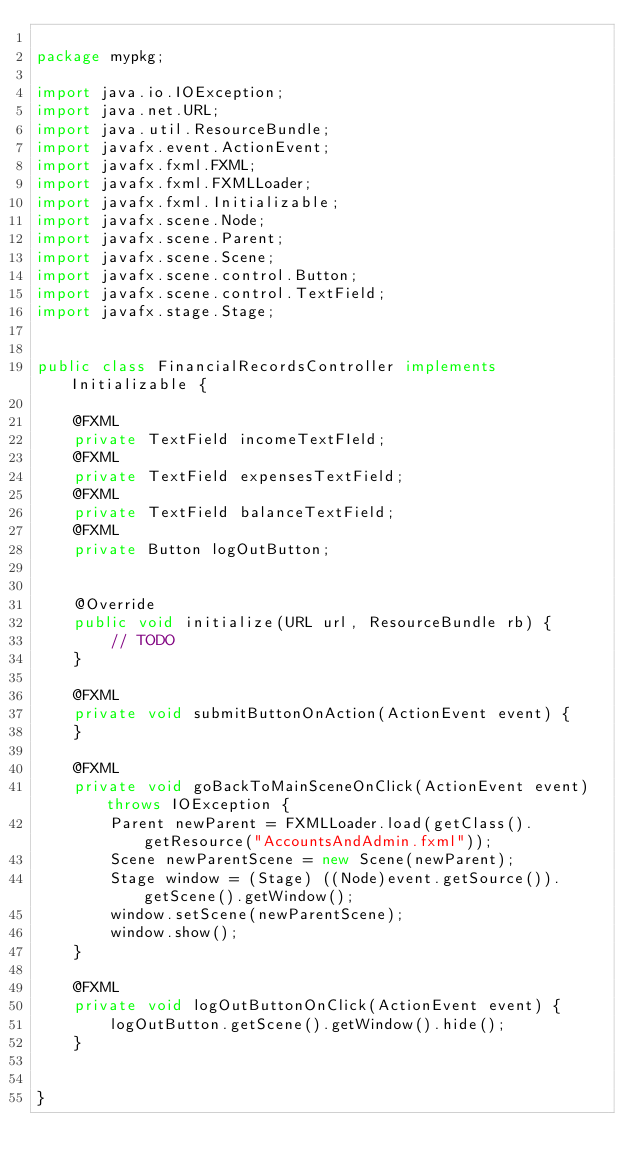<code> <loc_0><loc_0><loc_500><loc_500><_Java_> 
package mypkg;

import java.io.IOException;
import java.net.URL;
import java.util.ResourceBundle;
import javafx.event.ActionEvent;
import javafx.fxml.FXML;
import javafx.fxml.FXMLLoader;
import javafx.fxml.Initializable;
import javafx.scene.Node;
import javafx.scene.Parent;
import javafx.scene.Scene;
import javafx.scene.control.Button;
import javafx.scene.control.TextField;
import javafx.stage.Stage;

 
public class FinancialRecordsController implements Initializable {

    @FXML
    private TextField incomeTextFIeld;
    @FXML
    private TextField expensesTextField;
    @FXML
    private TextField balanceTextField;
    @FXML
    private Button logOutButton;

     
    @Override
    public void initialize(URL url, ResourceBundle rb) {
        // TODO
    }    

    @FXML
    private void submitButtonOnAction(ActionEvent event) {
    }

    @FXML
    private void goBackToMainSceneOnClick(ActionEvent event) throws IOException {
        Parent newParent = FXMLLoader.load(getClass().getResource("AccountsAndAdmin.fxml"));
        Scene newParentScene = new Scene(newParent);
        Stage window = (Stage) ((Node)event.getSource()).getScene().getWindow();
        window.setScene(newParentScene);
        window.show();
    }

    @FXML
    private void logOutButtonOnClick(ActionEvent event) {
        logOutButton.getScene().getWindow().hide();
    }
    
    
}
</code> 